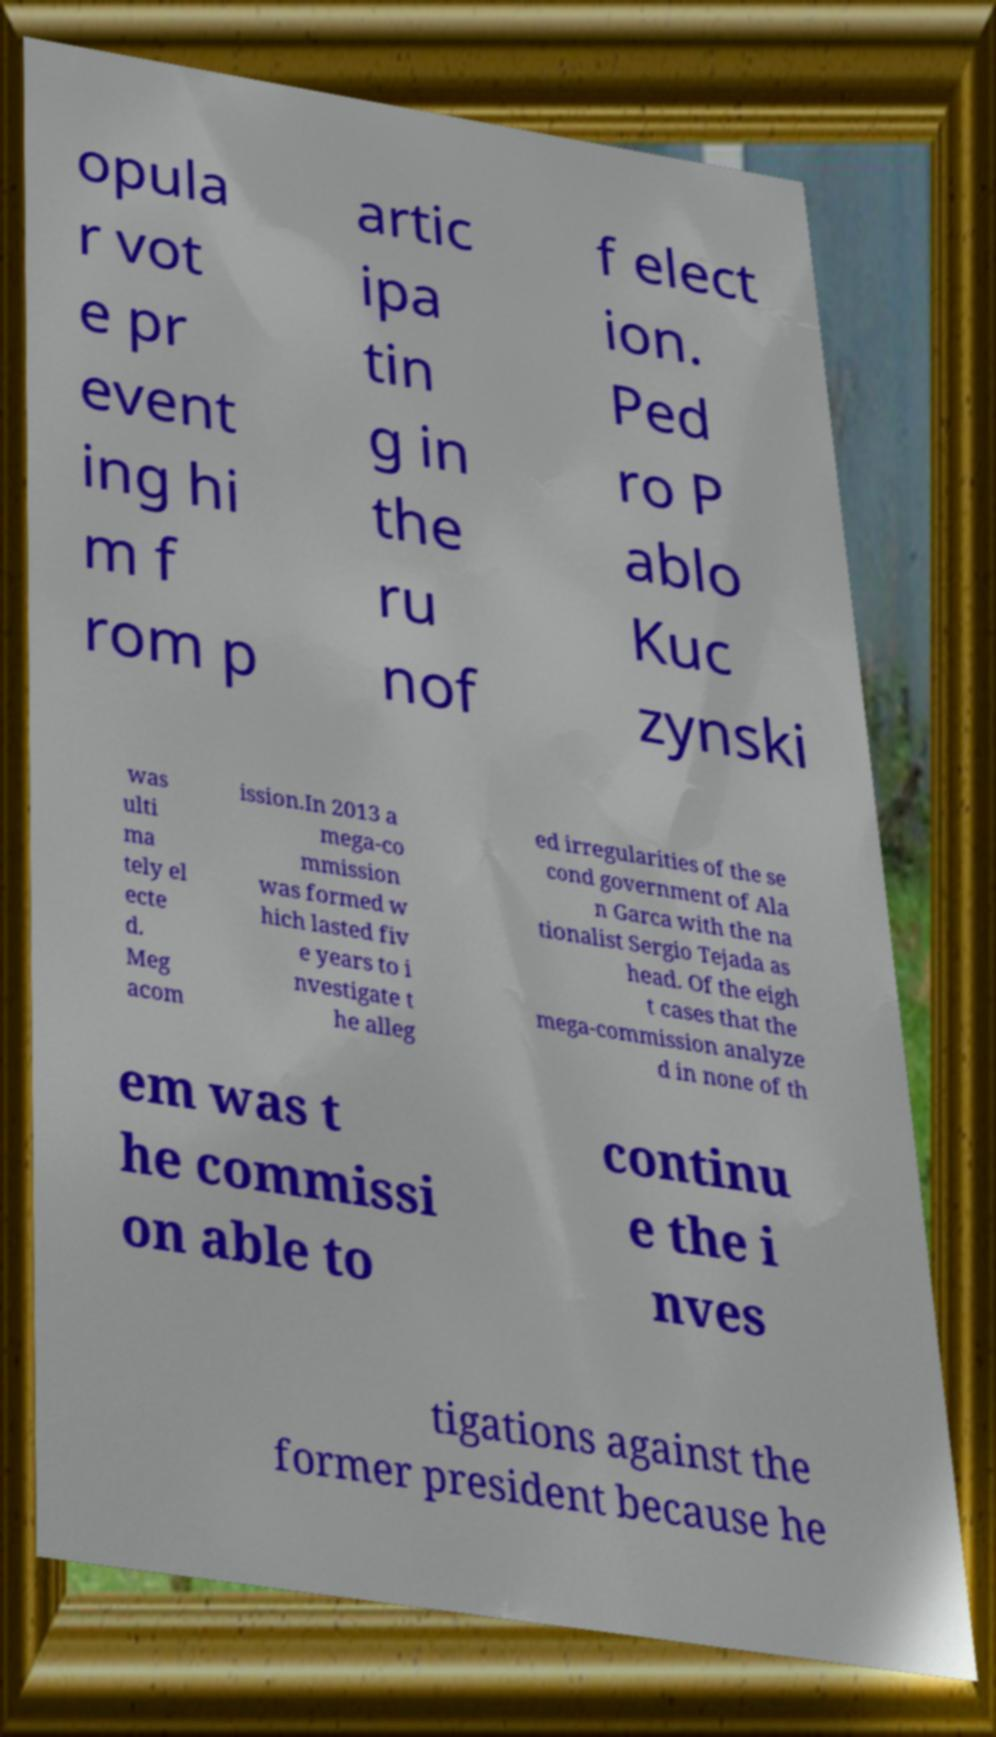Please identify and transcribe the text found in this image. opula r vot e pr event ing hi m f rom p artic ipa tin g in the ru nof f elect ion. Ped ro P ablo Kuc zynski was ulti ma tely el ecte d. Meg acom ission.In 2013 a mega-co mmission was formed w hich lasted fiv e years to i nvestigate t he alleg ed irregularities of the se cond government of Ala n Garca with the na tionalist Sergio Tejada as head. Of the eigh t cases that the mega-commission analyze d in none of th em was t he commissi on able to continu e the i nves tigations against the former president because he 